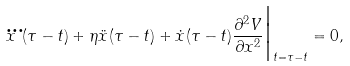<formula> <loc_0><loc_0><loc_500><loc_500>\dddot { x } ( \tau - t ) + \eta \ddot { x } ( \tau - t ) + \dot { x } ( \tau - t ) \frac { \partial ^ { 2 } V } { \partial x ^ { 2 } } \Big | _ { t = \tau - t } = 0 ,</formula> 